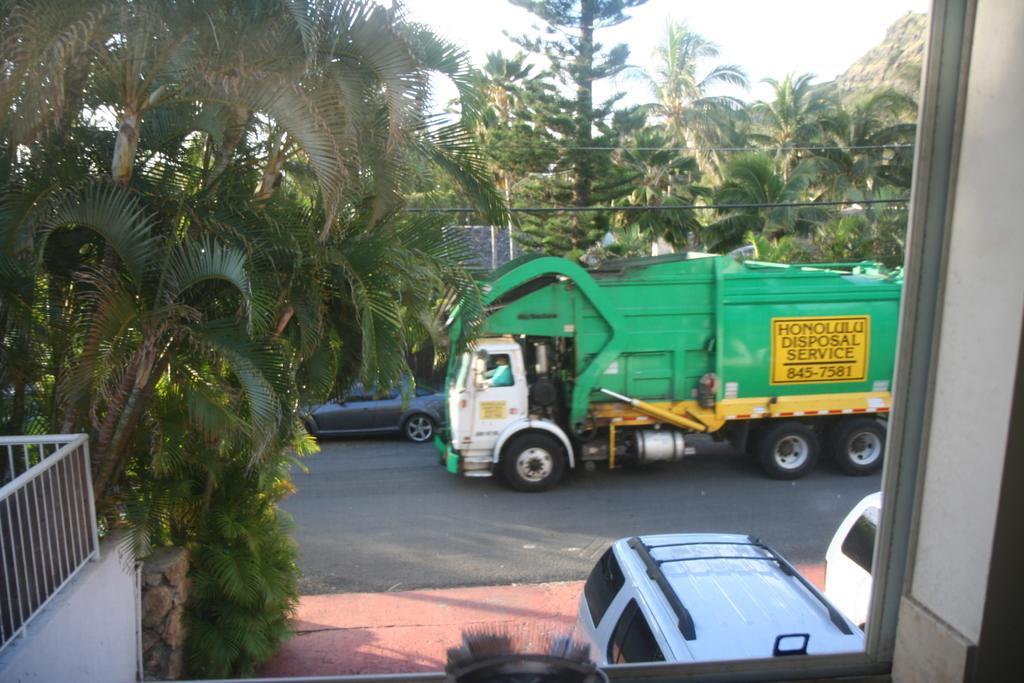Describe this image in one or two sentences. In this image I can see the railing, few vehicles which are white in color on the ground, the road, a truck and a car on the road and in the background I can see few trees, few wires, a mountain and the sky. To the right side of the image I can see the white colored wall. 